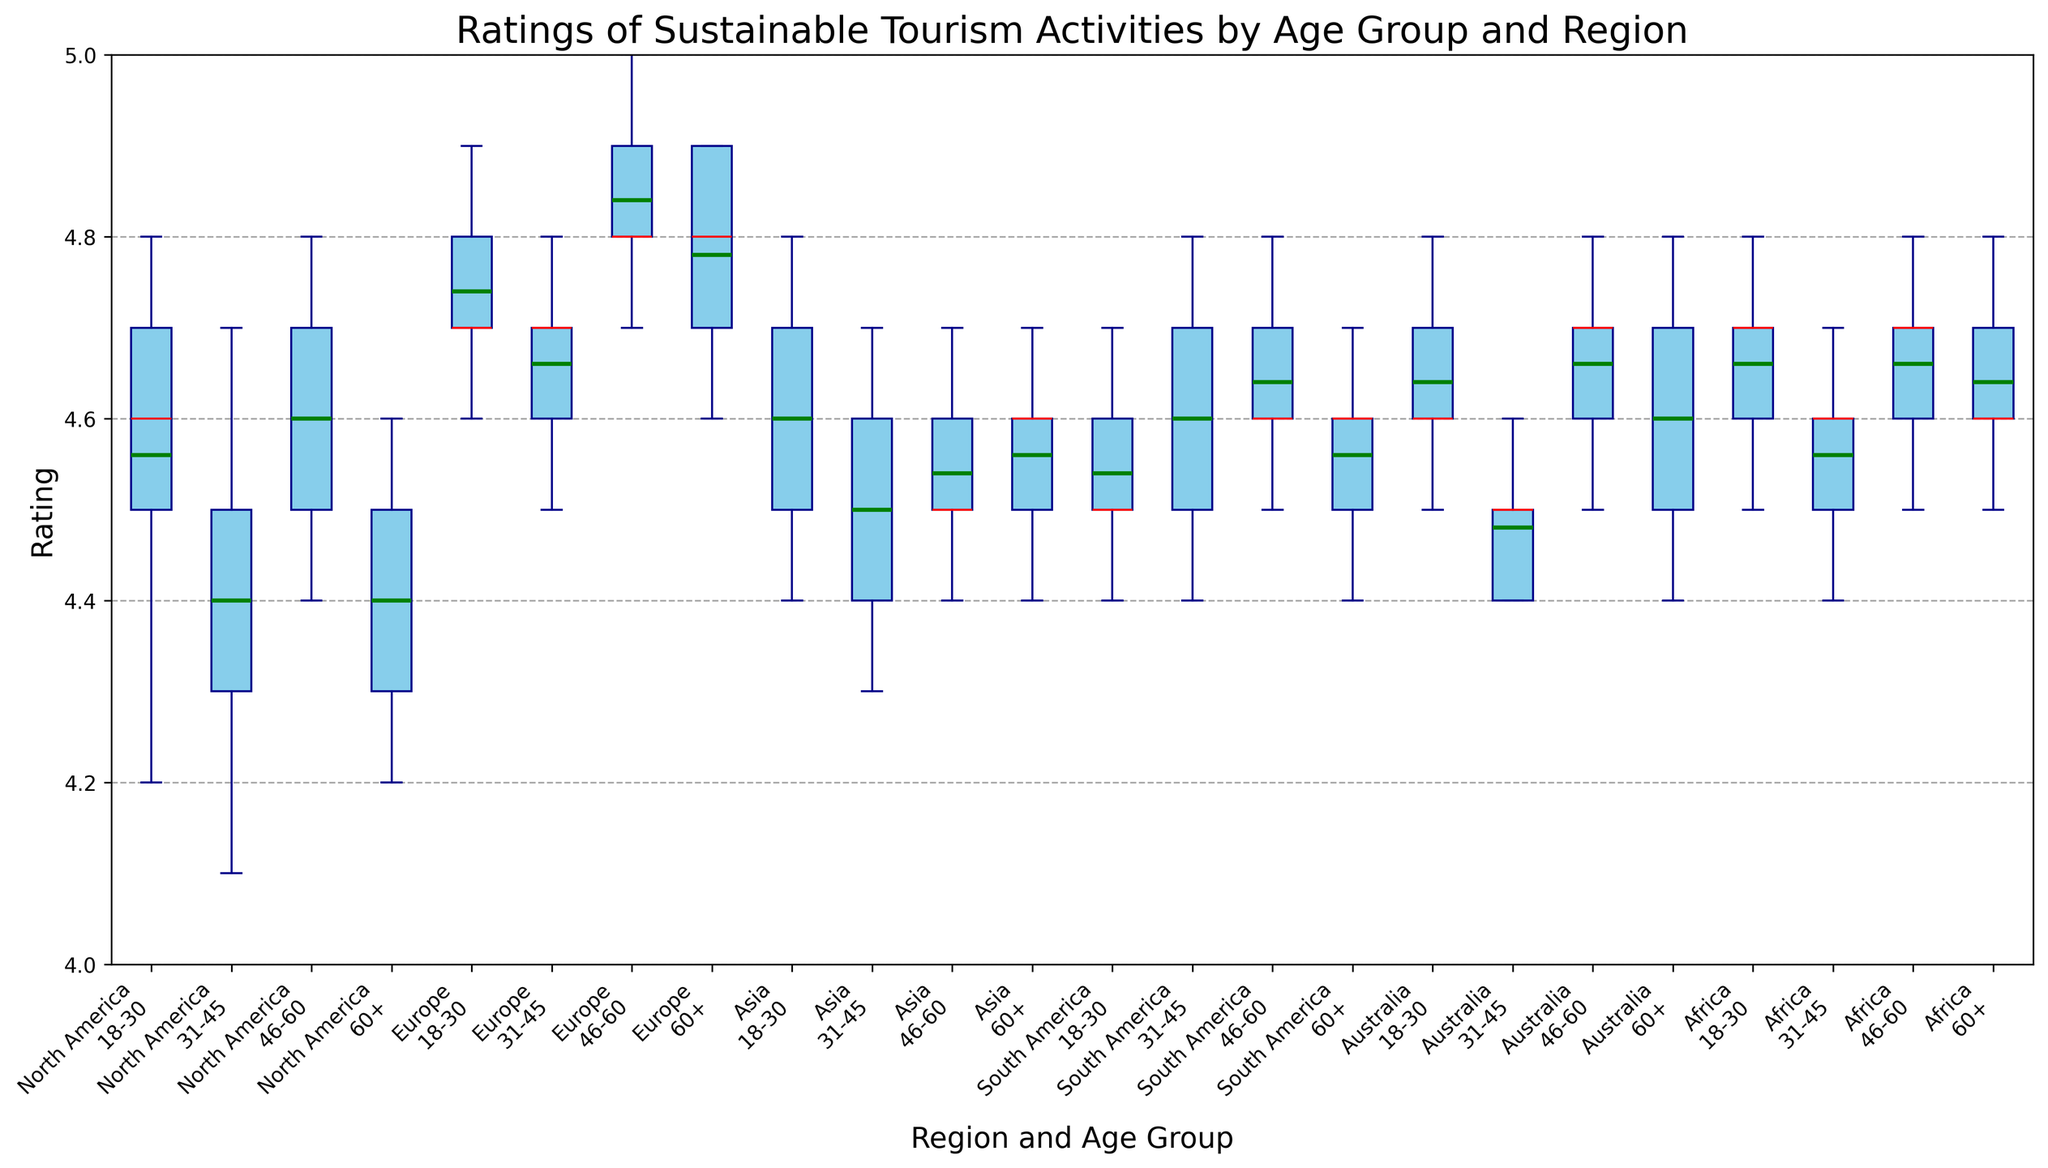1. Which region and age group has the highest median rating? To determine the highest median rating, observe the central line (red) in each box plot which indicates the median for each region-age group combination. Compare these median lines across all plots.
Answer: Europe, 46-60 2. Do any regions have mean ratings marked by the green line closer to the bottom of the box in any age group? The green line represents the mean. Examine the position of the green line in each box plot compared to the lower quartile (bottom of the box).
Answer: No 3. Which region shows the smallest IQR (Interquartile Range) for the 18-30 age group? The IQR is represented by the height of the box. For each region in the 18-30 age group, measure the height of the box (distance between top and bottom edges of the box).
Answer: South America 4. How does the variability in ratings for Europe aged 60+ compare to those aged 18-30 in the same region? Assess the spread of the boxes and the length of the whiskers for Europe in both age groups. Greater spread and longer whiskers indicate higher variability.
Answer: 60+ has wider spread than 18-30 5. Are there any outliers in the ratings for North America aged 18-30? Outliers are represented by any points that fall outside the whiskers. Check for any individual points beyond the whiskers in the North America 18-30 box plot.
Answer: No 6. Compare the median ratings for Asian participants aged 46-60 and African participants aged 60+. Which is higher? Locate the median lines for both Asian 46-60 and African 60+ box plots and compare their vertical positions.
Answer: African 60+ 7. Among South America and Australia for the 31-45 age group, which has the higher mean rating? Look for the position of the green line in the boxes representing the 31-45 age group for South America and Australia. The higher green line indicates a higher mean rating.
Answer: South America 8. In which age group does Africa have the most consistent ratings? Consistent ratings are indicated by a smaller IQR (smaller box height) and shorter whiskers. Compare the box heights and whisker lengths for each age group in Africa.
Answer: 31-45 9. Which age group has the lowest median rating in North America? Identify the red median lines for each age group in North America and determine which is the lowest in position.
Answer: 31-45 10. Are the ratings for sustainable tourism activities more spread out for Europe aged 60+ or for Australia aged 46-60? Compare the total length from the bottom whisker to the top whisker for Europe aged 60+ and Australia aged 46-60.
Answer: Europe aged 60+ has more spread 